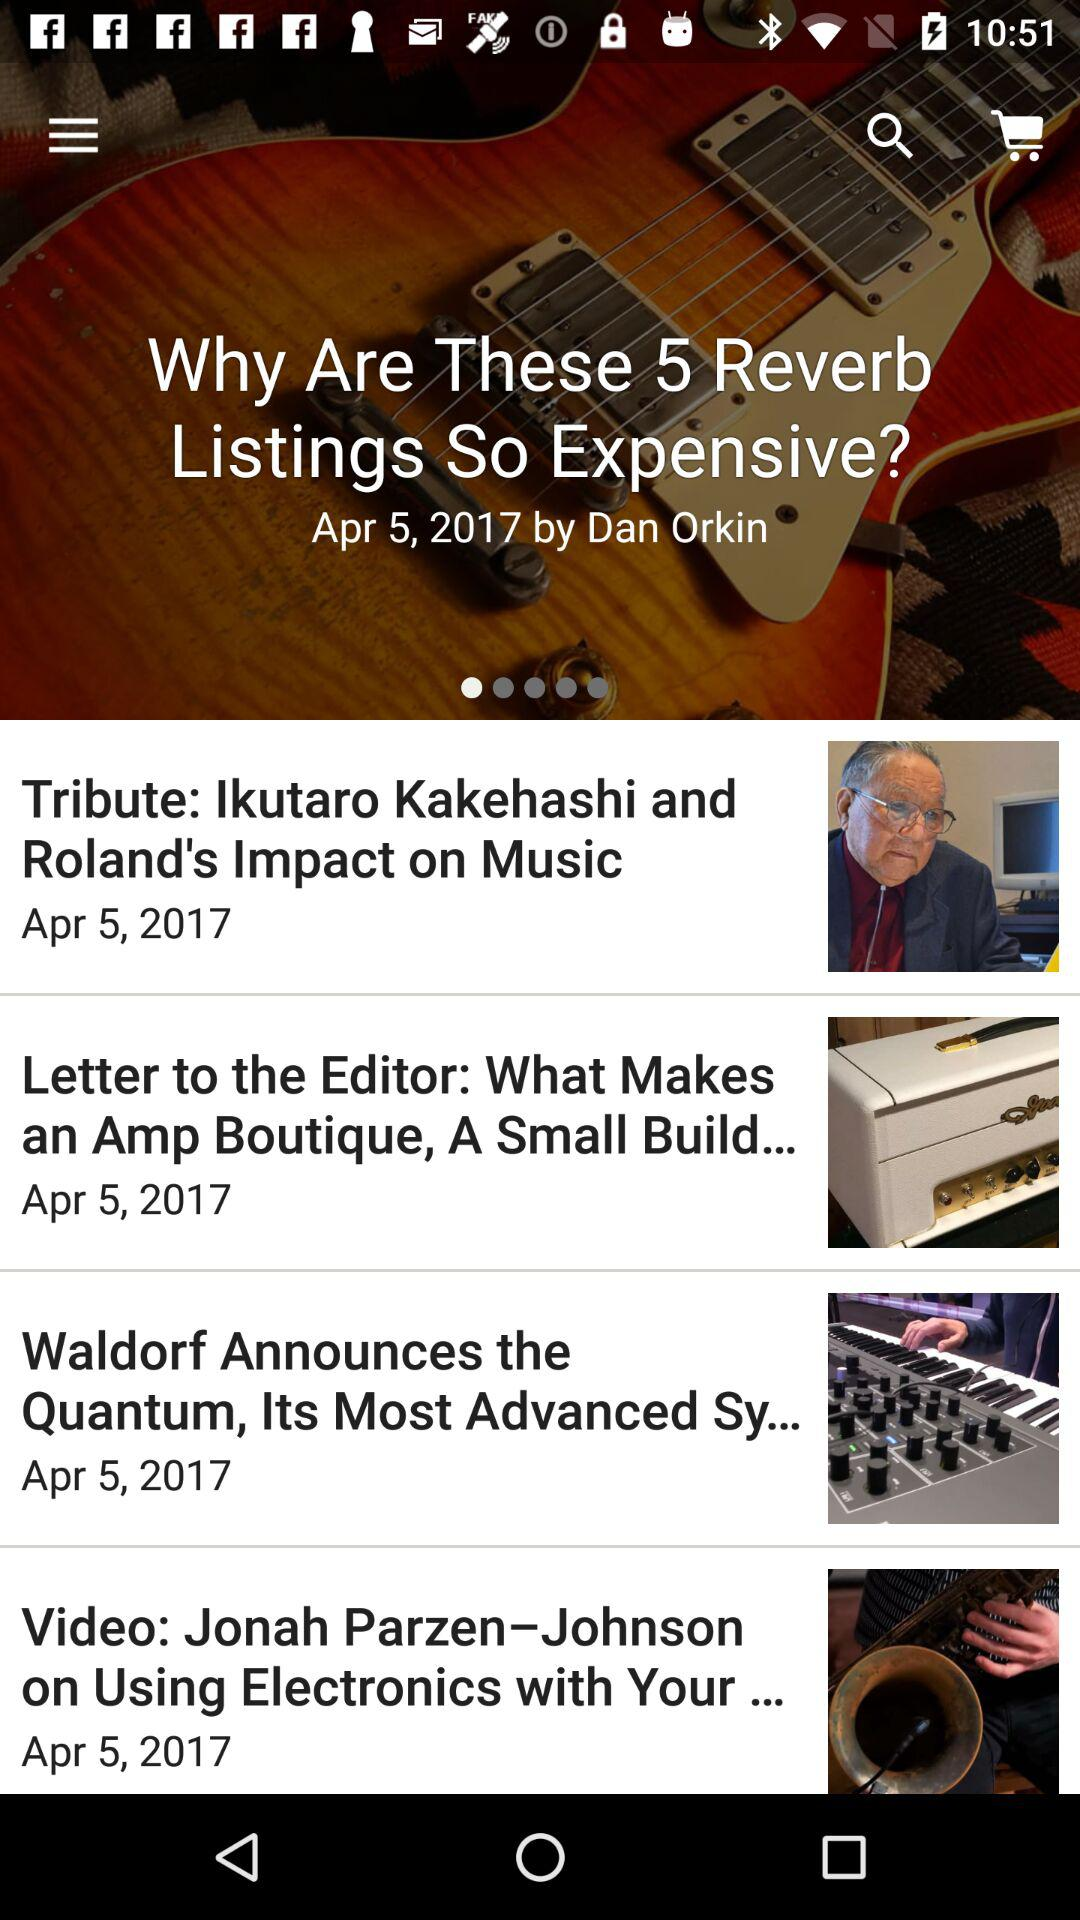Who is the author of this article? The author of this article is Dan Orkin. 